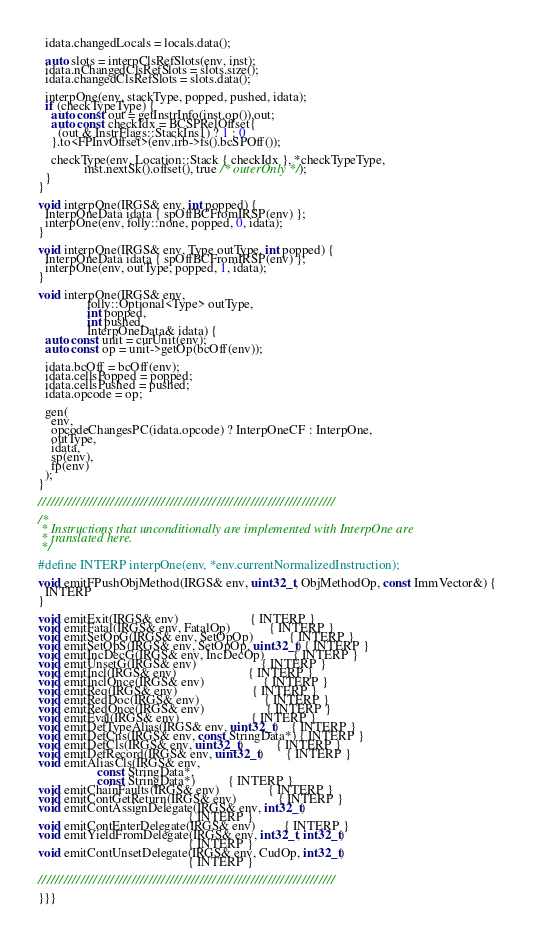<code> <loc_0><loc_0><loc_500><loc_500><_C++_>  idata.changedLocals = locals.data();

  auto slots = interpClsRefSlots(env, inst);
  idata.nChangedClsRefSlots = slots.size();
  idata.changedClsRefSlots = slots.data();

  interpOne(env, stackType, popped, pushed, idata);
  if (checkTypeType) {
    auto const out = getInstrInfo(inst.op()).out;
    auto const checkIdx = BCSPRelOffset{
      (out & InstrFlags::StackIns1) ? 1 : 0
    }.to<FPInvOffset>(env.irb->fs().bcSPOff());

    checkType(env, Location::Stack { checkIdx }, *checkTypeType,
              inst.nextSk().offset(), true /* outerOnly */);
  }
}

void interpOne(IRGS& env, int popped) {
  InterpOneData idata { spOffBCFromIRSP(env) };
  interpOne(env, folly::none, popped, 0, idata);
}

void interpOne(IRGS& env, Type outType, int popped) {
  InterpOneData idata { spOffBCFromIRSP(env) };
  interpOne(env, outType, popped, 1, idata);
}

void interpOne(IRGS& env,
               folly::Optional<Type> outType,
               int popped,
               int pushed,
               InterpOneData& idata) {
  auto const unit = curUnit(env);
  auto const op = unit->getOp(bcOff(env));

  idata.bcOff = bcOff(env);
  idata.cellsPopped = popped;
  idata.cellsPushed = pushed;
  idata.opcode = op;

  gen(
    env,
    opcodeChangesPC(idata.opcode) ? InterpOneCF : InterpOne,
    outType,
    idata,
    sp(env),
    fp(env)
  );
}

//////////////////////////////////////////////////////////////////////

/*
 * Instructions that unconditionally are implemented with InterpOne are
 * translated here.
 */

#define INTERP interpOne(env, *env.currentNormalizedInstruction);

void emitFPushObjMethod(IRGS& env, uint32_t, ObjMethodOp, const ImmVector&) {
  INTERP
}

void emitExit(IRGS& env)                      { INTERP }
void emitFatal(IRGS& env, FatalOp)            { INTERP }
void emitSetOpG(IRGS& env, SetOpOp)           { INTERP }
void emitSetOpS(IRGS& env, SetOpOp, uint32_t) { INTERP }
void emitIncDecG(IRGS& env, IncDecOp)         { INTERP }
void emitUnsetG(IRGS& env)                    { INTERP }
void emitIncl(IRGS& env)                      { INTERP }
void emitInclOnce(IRGS& env)                  { INTERP }
void emitReq(IRGS& env)                       { INTERP }
void emitReqDoc(IRGS& env)                    { INTERP }
void emitReqOnce(IRGS& env)                   { INTERP }
void emitEval(IRGS& env)                      { INTERP }
void emitDefTypeAlias(IRGS& env, uint32_t)    { INTERP }
void emitDefCns(IRGS& env, const StringData*) { INTERP }
void emitDefCls(IRGS& env, uint32_t)          { INTERP }
void emitDefRecord(IRGS& env, uint32_t)       { INTERP }
void emitAliasCls(IRGS& env,
                  const StringData*,
                  const StringData*)          { INTERP }
void emitChainFaults(IRGS& env)               { INTERP }
void emitContGetReturn(IRGS& env)             { INTERP }
void emitContAssignDelegate(IRGS& env, int32_t)
                                              { INTERP }
void emitContEnterDelegate(IRGS& env)         { INTERP }
void emitYieldFromDelegate(IRGS& env, int32_t, int32_t)
                                              { INTERP }
void emitContUnsetDelegate(IRGS& env, CudOp, int32_t)
                                              { INTERP }

//////////////////////////////////////////////////////////////////////

}}}
</code> 